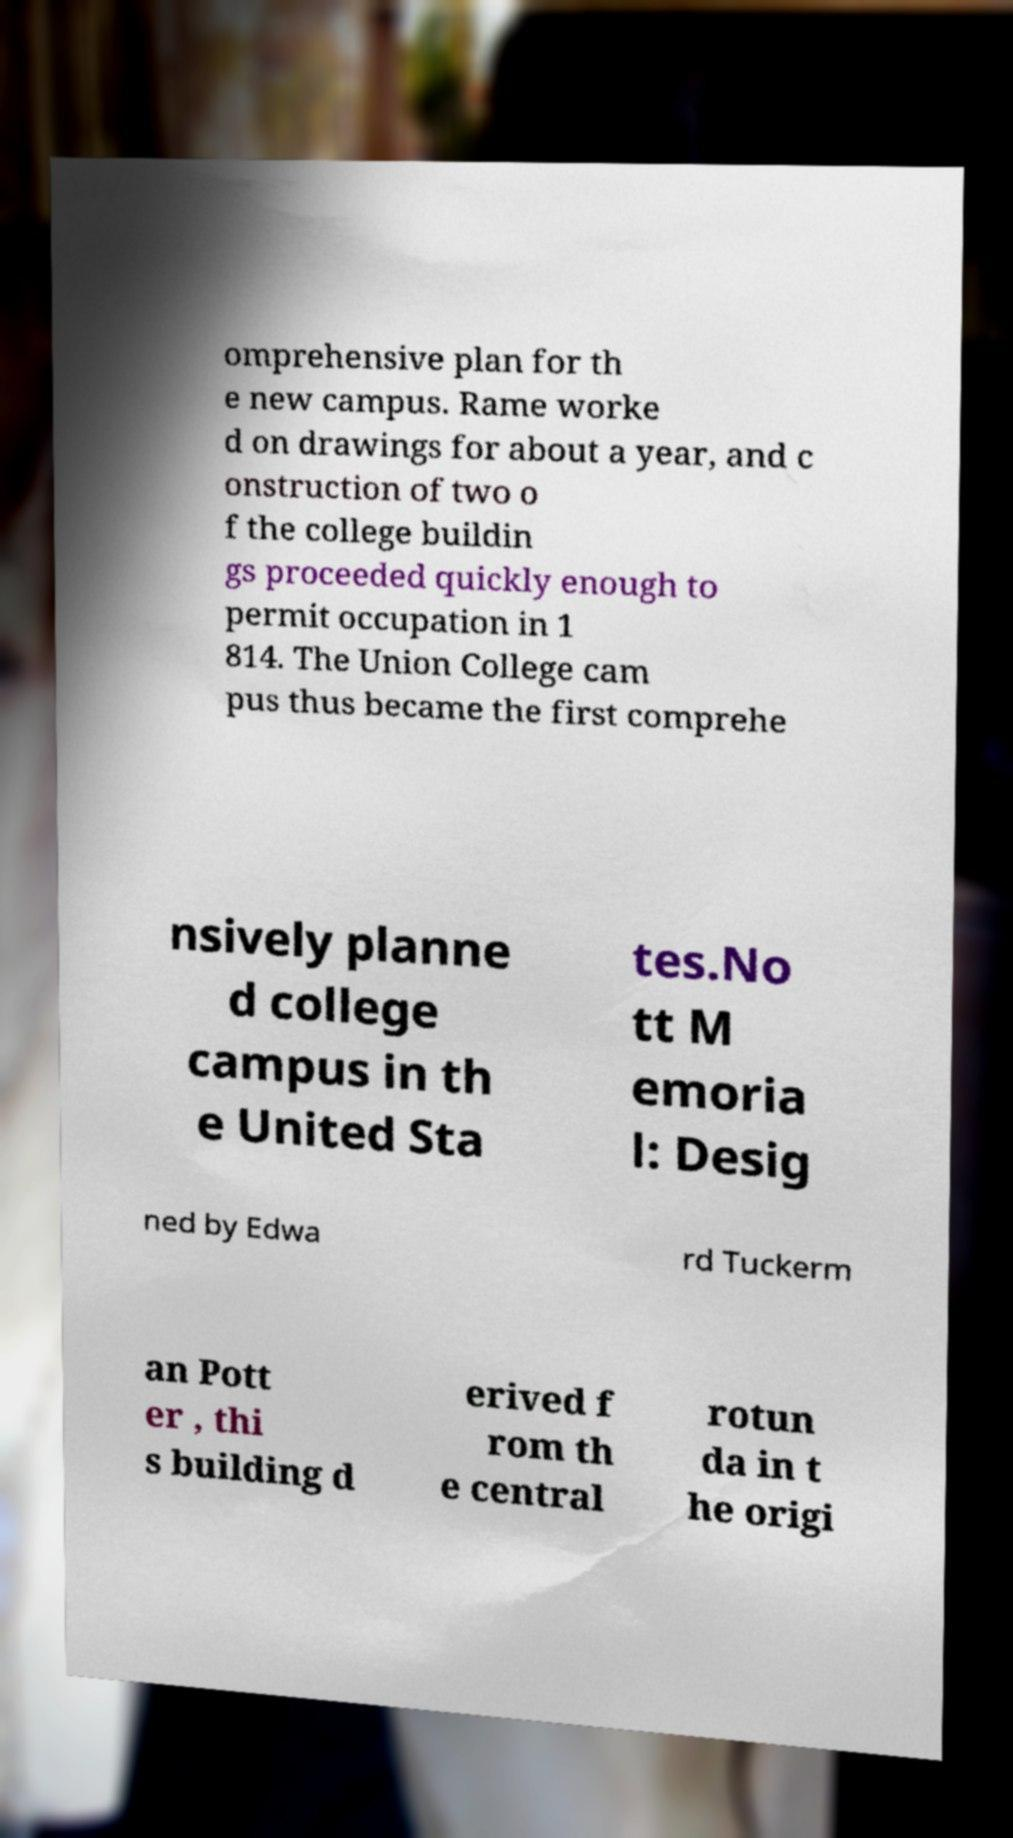Can you read and provide the text displayed in the image?This photo seems to have some interesting text. Can you extract and type it out for me? omprehensive plan for th e new campus. Rame worke d on drawings for about a year, and c onstruction of two o f the college buildin gs proceeded quickly enough to permit occupation in 1 814. The Union College cam pus thus became the first comprehe nsively planne d college campus in th e United Sta tes.No tt M emoria l: Desig ned by Edwa rd Tuckerm an Pott er , thi s building d erived f rom th e central rotun da in t he origi 